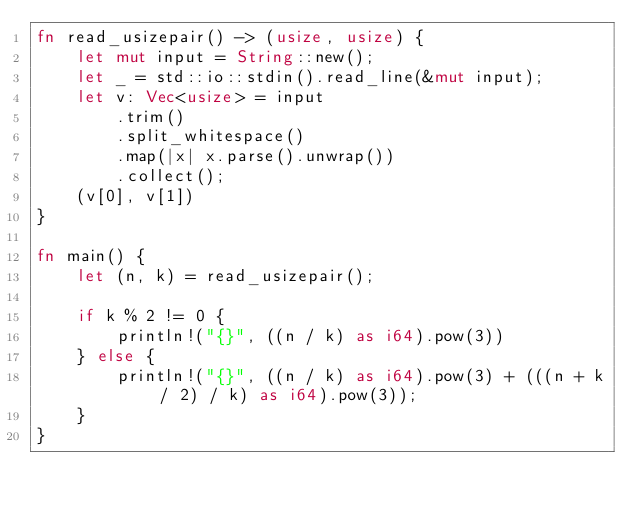Convert code to text. <code><loc_0><loc_0><loc_500><loc_500><_Rust_>fn read_usizepair() -> (usize, usize) {
    let mut input = String::new();
    let _ = std::io::stdin().read_line(&mut input);
    let v: Vec<usize> = input
        .trim()
        .split_whitespace()
        .map(|x| x.parse().unwrap())
        .collect();
    (v[0], v[1])
}

fn main() {
    let (n, k) = read_usizepair();

    if k % 2 != 0 {
        println!("{}", ((n / k) as i64).pow(3))
    } else {
        println!("{}", ((n / k) as i64).pow(3) + (((n + k / 2) / k) as i64).pow(3));
    }
}</code> 